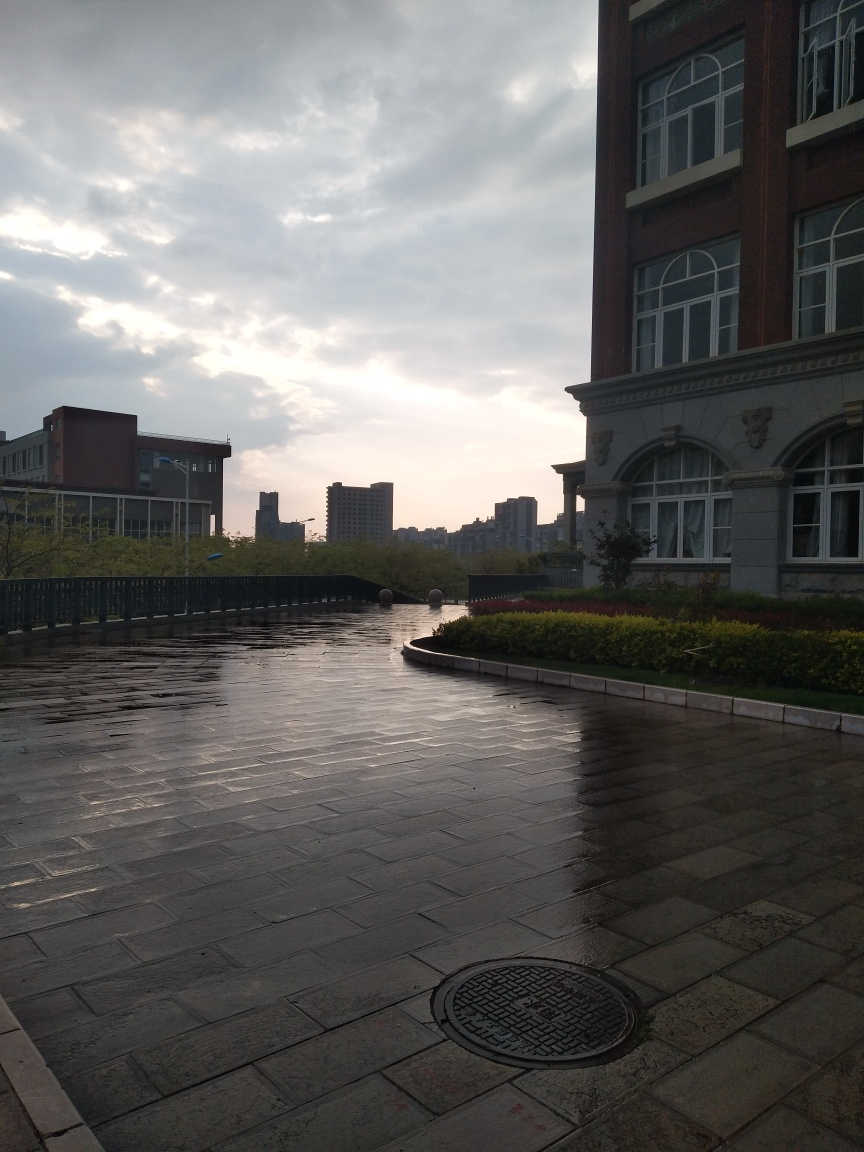What time of day does this photo appear to be taken? The photo looks like it was taken either in the early morning or late afternoon, as suggested by the long shadows cast on the wet ground and the soft, diffused sunlight filtering through the clouds. 